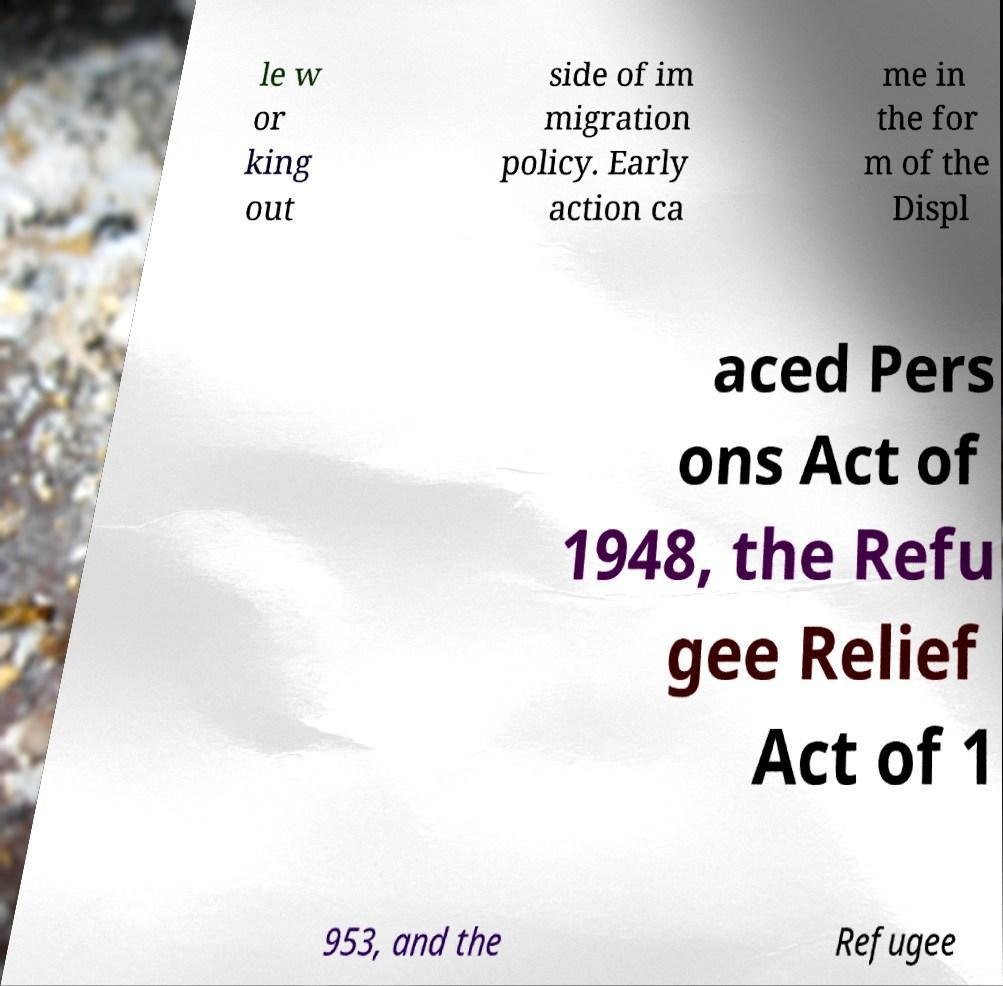Please identify and transcribe the text found in this image. le w or king out side of im migration policy. Early action ca me in the for m of the Displ aced Pers ons Act of 1948, the Refu gee Relief Act of 1 953, and the Refugee 